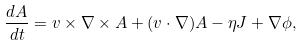Convert formula to latex. <formula><loc_0><loc_0><loc_500><loc_500>\frac { d { A } } { d t } = { v } \times \nabla \times { A } + ( { v } \cdot \nabla ) { A } - \eta { J } + \nabla \phi ,</formula> 